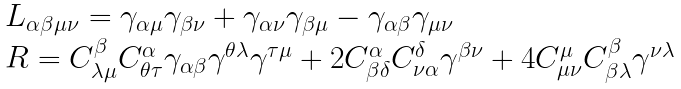<formula> <loc_0><loc_0><loc_500><loc_500>\begin{array} { l l } L _ { \alpha \beta \mu \nu } = \gamma _ { \alpha \mu } \gamma _ { \beta \nu } + \gamma _ { \alpha \nu } \gamma _ { \beta \mu } - \gamma _ { \alpha \beta } \gamma _ { \mu \nu } \\ R = C ^ { \beta } _ { \lambda \mu } C ^ { \alpha } _ { \theta \tau } \gamma _ { \alpha \beta } \gamma ^ { \theta \lambda } \gamma ^ { \tau \mu } + 2 C ^ { \alpha } _ { \beta \delta } C ^ { \delta } _ { \nu \alpha } \gamma ^ { \beta \nu } + 4 C ^ { \mu } _ { \mu \nu } C ^ { \beta } _ { \beta \lambda } \gamma ^ { \nu \lambda } \end{array}</formula> 